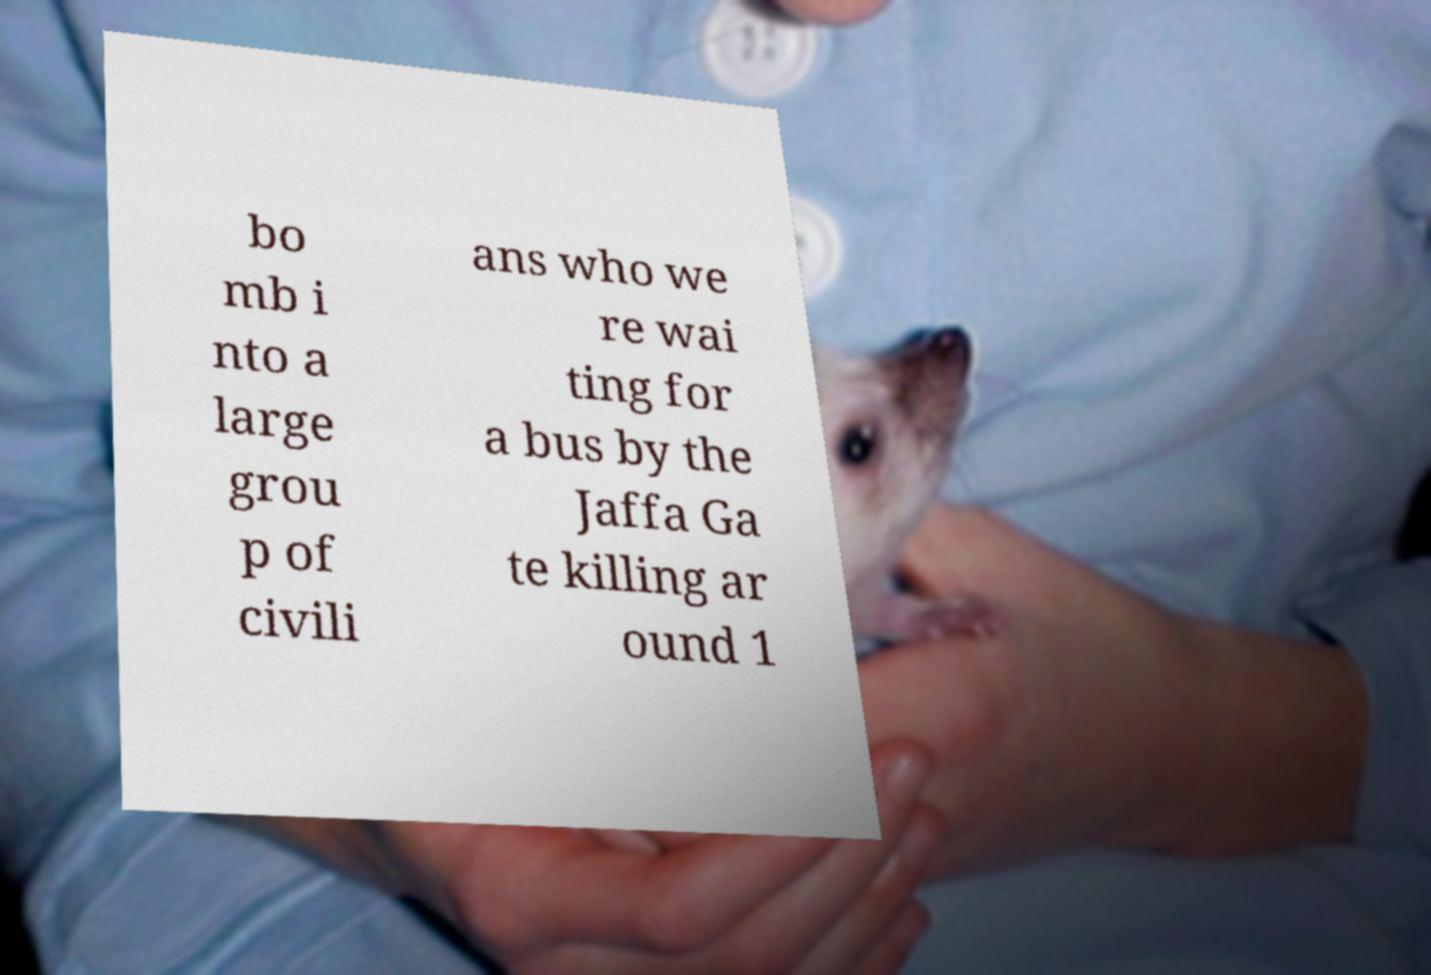Can you accurately transcribe the text from the provided image for me? bo mb i nto a large grou p of civili ans who we re wai ting for a bus by the Jaffa Ga te killing ar ound 1 